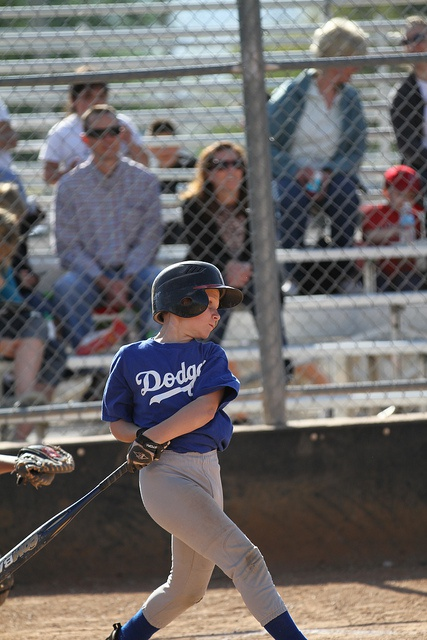Describe the objects in this image and their specific colors. I can see people in darkgreen, gray, navy, and black tones, people in darkgreen, gray, navy, and black tones, people in darkgreen, gray, black, darkgray, and blue tones, people in darkgreen, black, gray, brown, and darkgray tones, and people in darkgreen, gray, black, and blue tones in this image. 